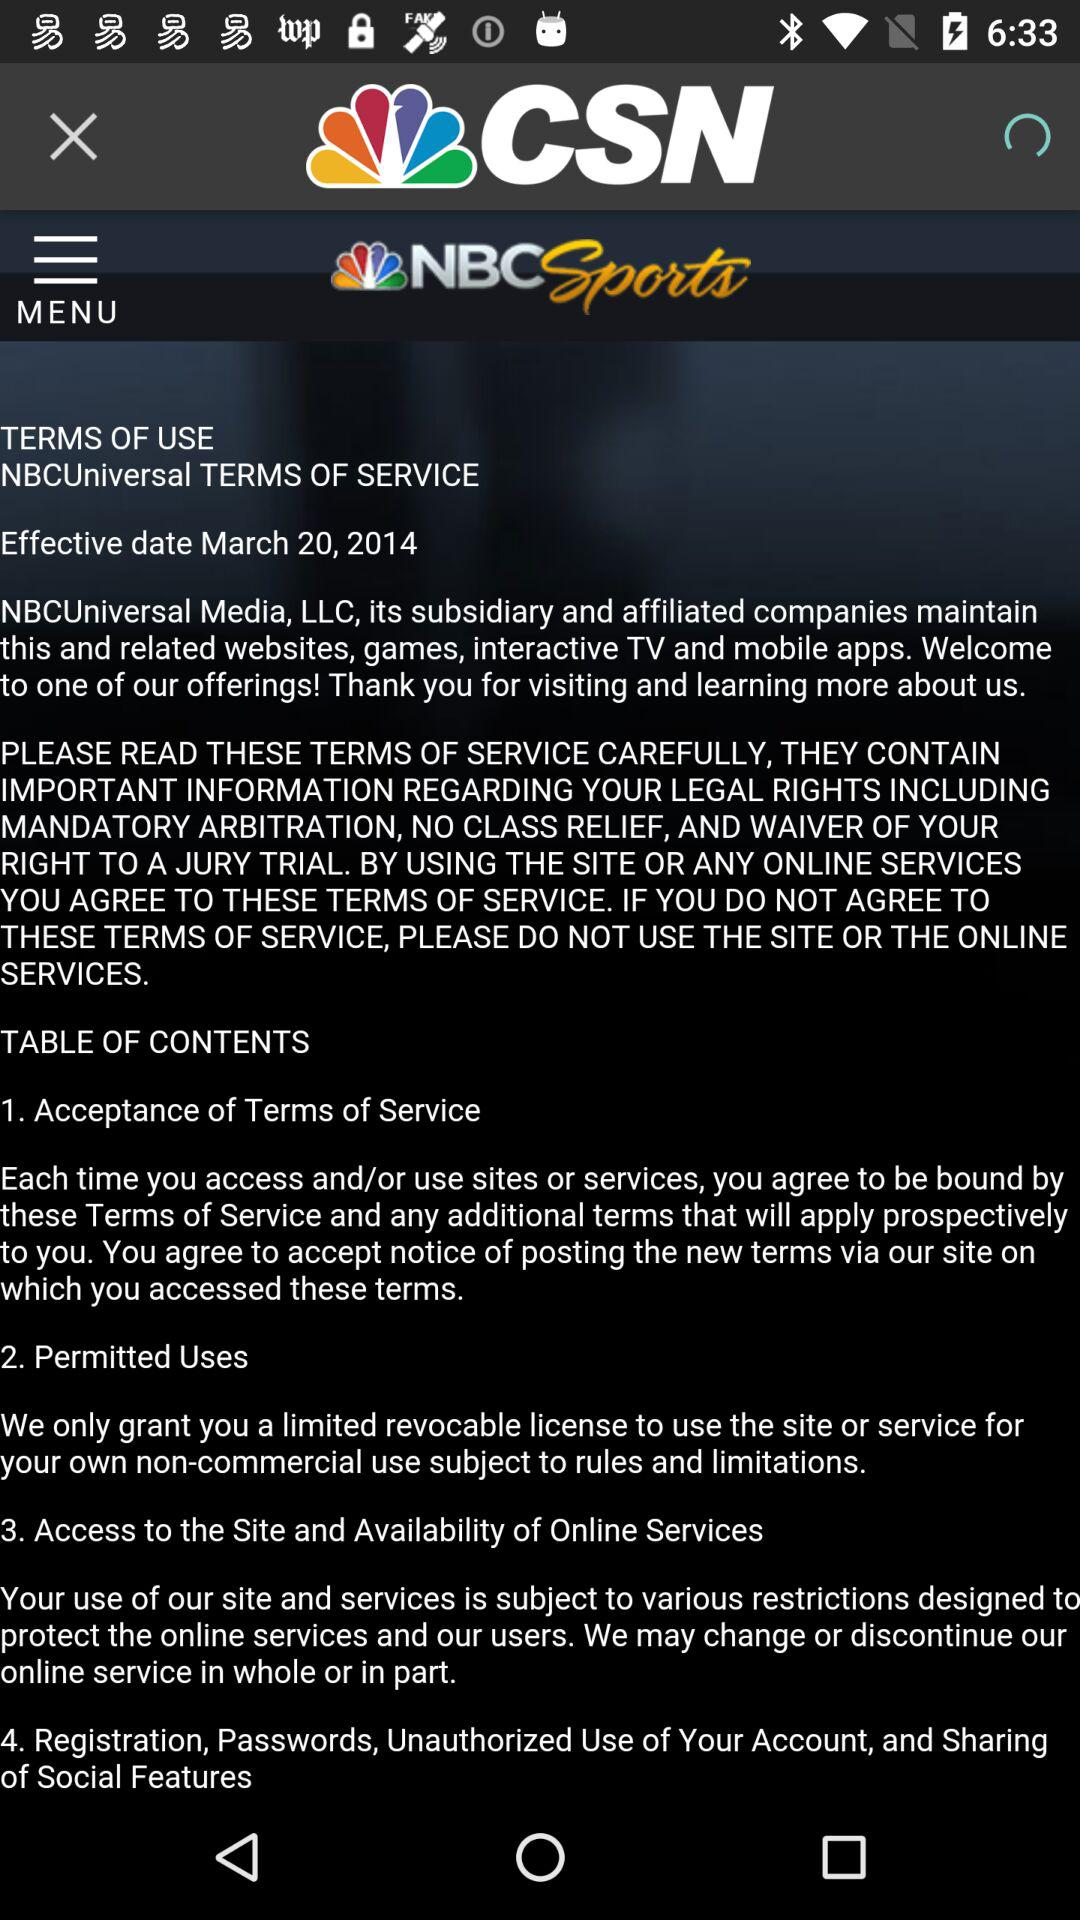How many terms of service are there?
Answer the question using a single word or phrase. 4 